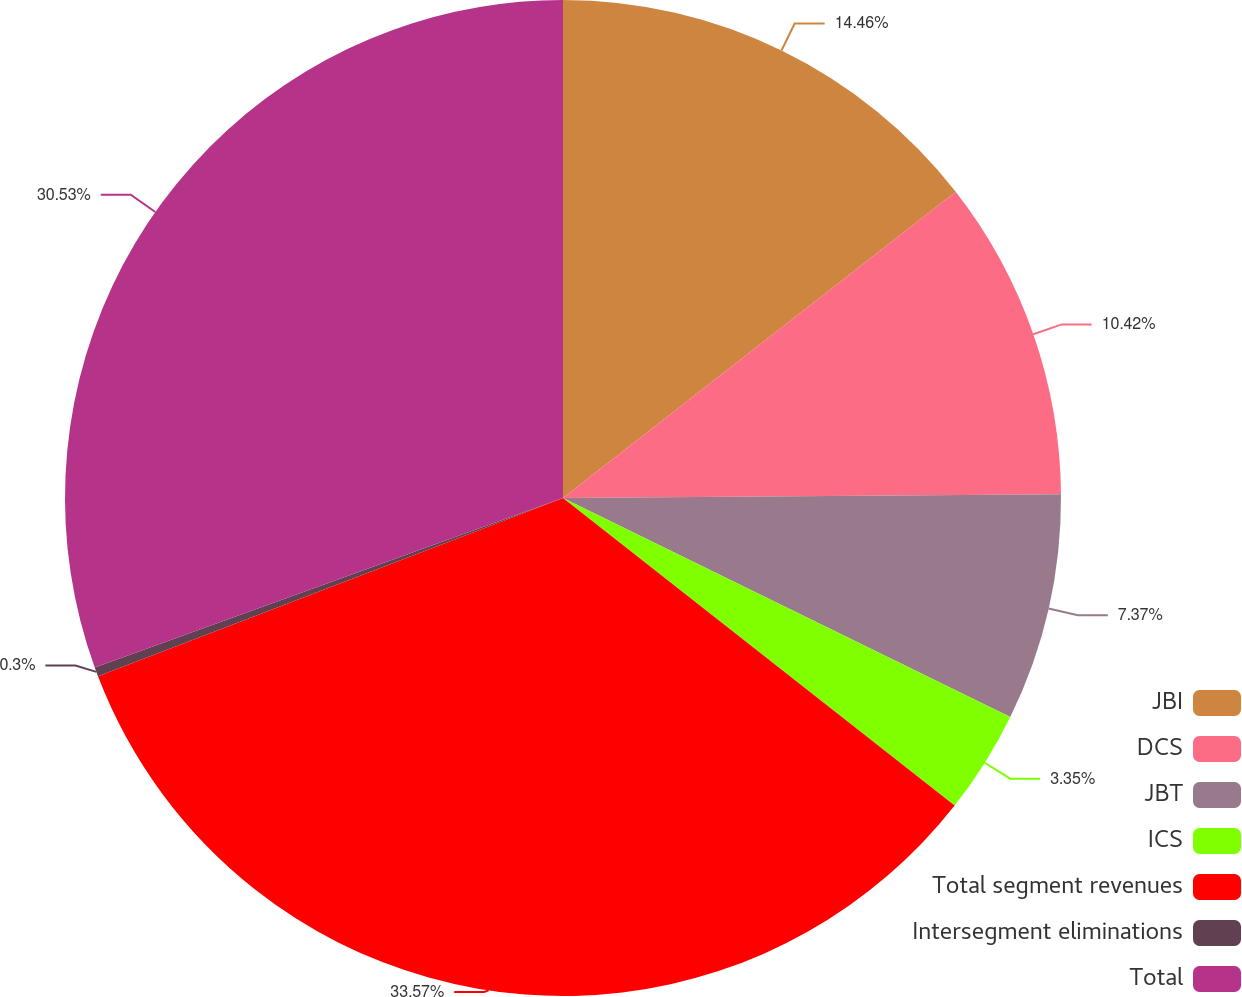<chart> <loc_0><loc_0><loc_500><loc_500><pie_chart><fcel>JBI<fcel>DCS<fcel>JBT<fcel>ICS<fcel>Total segment revenues<fcel>Intersegment eliminations<fcel>Total<nl><fcel>14.46%<fcel>10.42%<fcel>7.37%<fcel>3.35%<fcel>33.58%<fcel>0.3%<fcel>30.53%<nl></chart> 